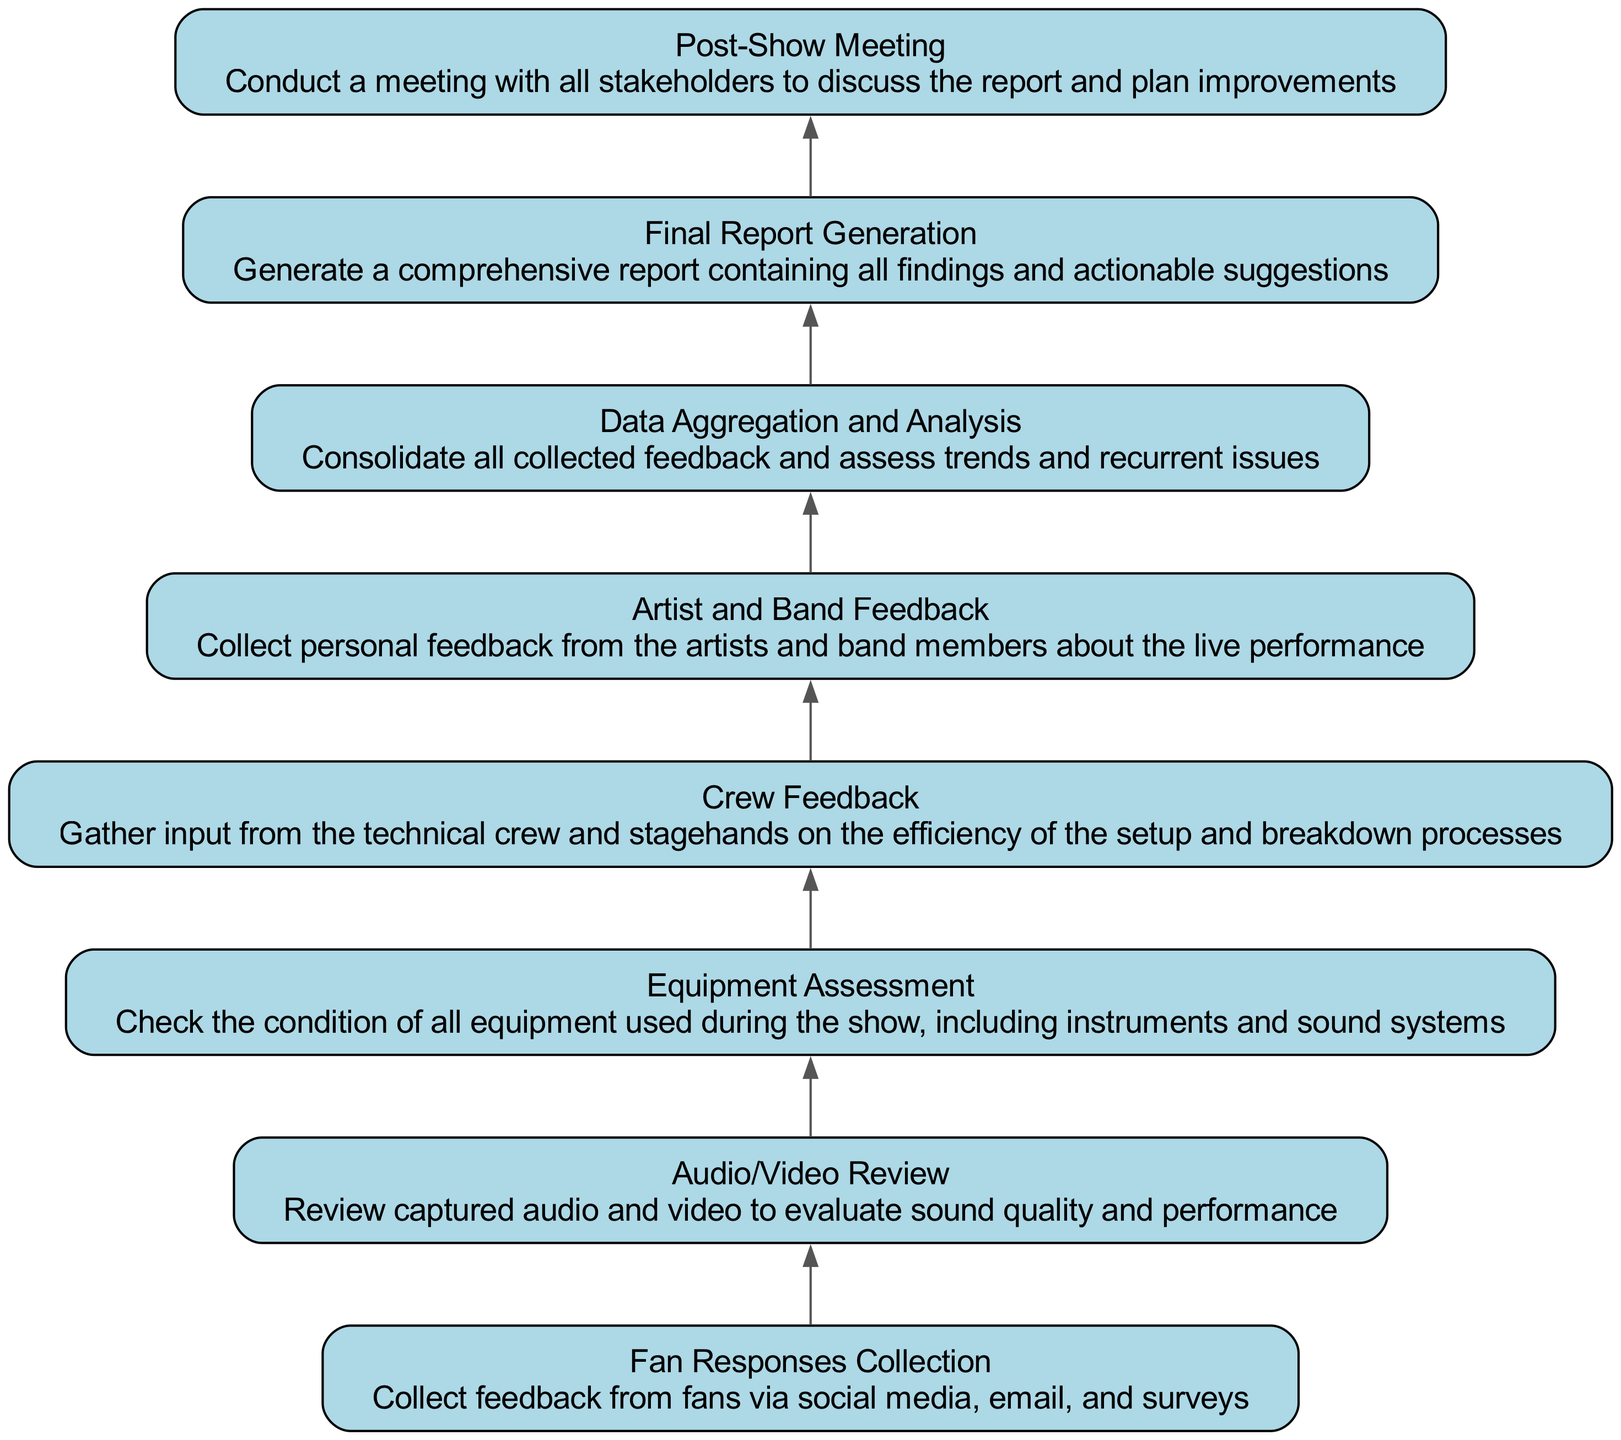What is the first step in the process? The first step in the process, as indicated in the diagram, is "Fan Responses Collection." This is the bottom node, and it represents the starting point of the sequence of actions taken after the show.
Answer: Fan Responses Collection How many nodes are there in the flow chart? The flow chart contains eight nodes, each representing a specific step in the feedback collection and analysis process, starting from fan responses to the final report generation.
Answer: 8 What comes after "Equipment Assessment"? Following "Equipment Assessment," the next step in the flow chart is "Crew Feedback." This shows the order of operations; equipment assessment is assessed before gathering feedback from the crew.
Answer: Crew Feedback Which step directly leads to "Final Report Generation"? The step that directly leads to "Final Report Generation" is "Data Aggregation and Analysis." This indicates that the consolidation and review of feedback is necessary before generating the comprehensive report.
Answer: Data Aggregation and Analysis What type of feedback is collected from the artists? Feedback collected from the artists is labeled as "Artist and Band Feedback." This specifically refers to the personal feedback received from the performers about their live performance experience.
Answer: Artist and Band Feedback What is the last action in the process? The last action in the process, represented at the top of the flow chart, is "Post-Show Meeting." This concludes the series of actions mandated by the feedback collection and reporting process post-show.
Answer: Post-Show Meeting Which steps involve gathering feedback? The steps that involve gathering feedback include "Fan Responses Collection," "Crew Feedback," and "Artist and Band Feedback." These steps are expressly dedicated to collecting input from different stakeholders involved in the show.
Answer: Fan Responses Collection, Crew Feedback, Artist and Band Feedback What is the function of "Data Aggregation and Analysis"? The function of "Data Aggregation and Analysis" is to consolidate all collected feedback and assess trends and recurrent issues, summarizing the entire feedback process into actionable insights.
Answer: Consolidate feedback and assess trends 